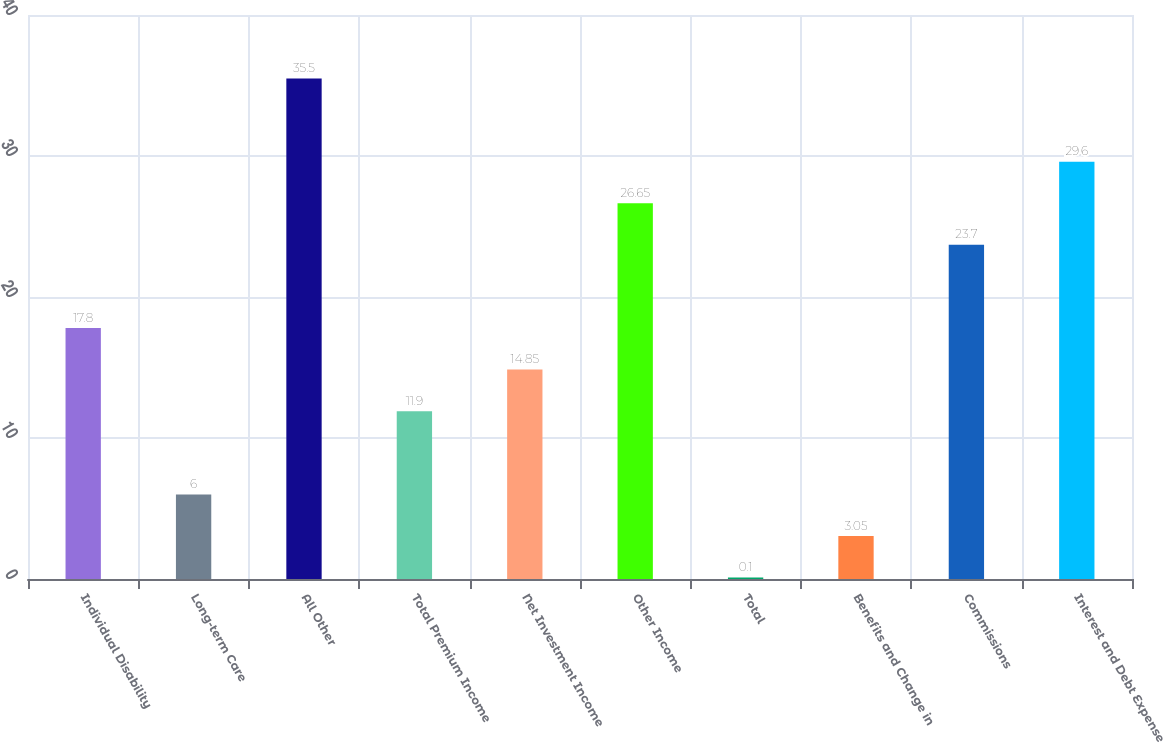Convert chart. <chart><loc_0><loc_0><loc_500><loc_500><bar_chart><fcel>Individual Disability<fcel>Long-term Care<fcel>All Other<fcel>Total Premium Income<fcel>Net Investment Income<fcel>Other Income<fcel>Total<fcel>Benefits and Change in<fcel>Commissions<fcel>Interest and Debt Expense<nl><fcel>17.8<fcel>6<fcel>35.5<fcel>11.9<fcel>14.85<fcel>26.65<fcel>0.1<fcel>3.05<fcel>23.7<fcel>29.6<nl></chart> 